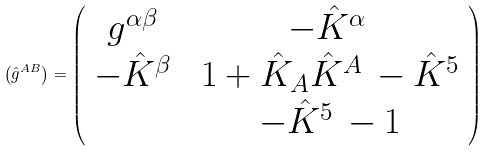<formula> <loc_0><loc_0><loc_500><loc_500>\left ( \hat { g } ^ { A B } \right ) = \left ( \begin{array} { c c } g ^ { \alpha \beta } \, & \, - \hat { K } ^ { \alpha } \, \\ - \hat { K } ^ { \beta } \, & \, 1 + \hat { K } _ { A } \hat { K } ^ { A } \, - \hat { K } ^ { 5 } \\ \, & \, - \hat { K } ^ { 5 } \, - 1 \end{array} \right )</formula> 